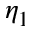Convert formula to latex. <formula><loc_0><loc_0><loc_500><loc_500>\eta _ { 1 }</formula> 